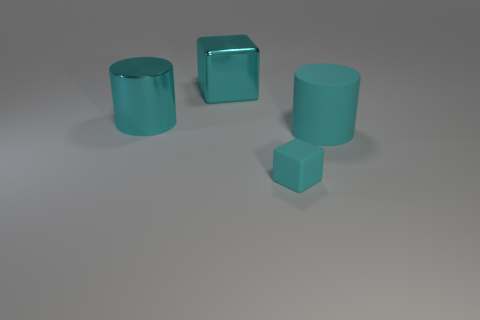Is there any other thing that has the same size as the matte block?
Keep it short and to the point. No. What size is the object that is both in front of the big cyan metallic block and behind the big cyan rubber cylinder?
Offer a terse response. Large. There is a metallic cube; how many large cyan matte things are left of it?
Ensure brevity in your answer.  0. There is a cyan object that is both behind the rubber cube and right of the large cyan metal block; what is its shape?
Your answer should be compact. Cylinder. What material is the small block that is the same color as the big cube?
Provide a short and direct response. Rubber. How many blocks are tiny green shiny objects or large cyan metallic things?
Your answer should be very brief. 1. The rubber block that is the same color as the large rubber cylinder is what size?
Provide a short and direct response. Small. Are there fewer things in front of the rubber cube than large metal cylinders?
Offer a terse response. Yes. The thing that is both in front of the large block and behind the big cyan matte cylinder is what color?
Keep it short and to the point. Cyan. How many other things are there of the same shape as the tiny matte object?
Make the answer very short. 1. 